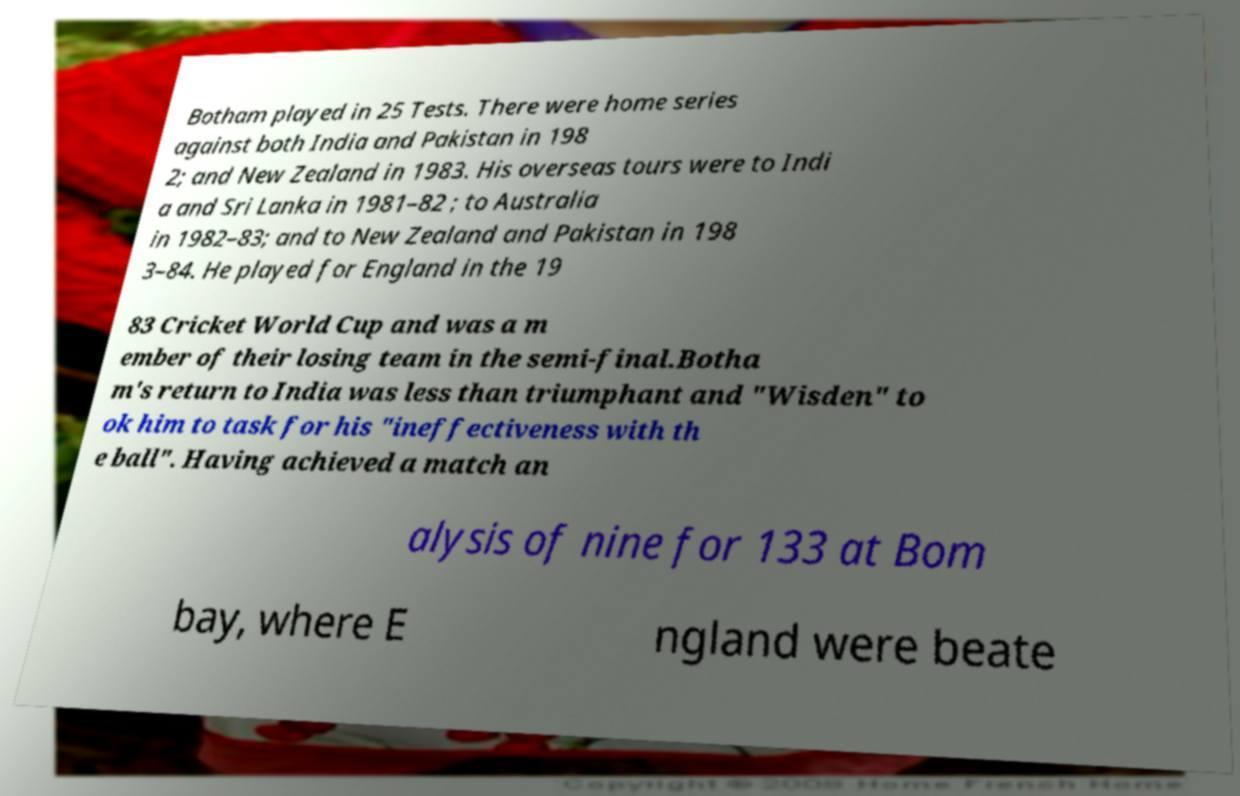There's text embedded in this image that I need extracted. Can you transcribe it verbatim? Botham played in 25 Tests. There were home series against both India and Pakistan in 198 2; and New Zealand in 1983. His overseas tours were to Indi a and Sri Lanka in 1981–82 ; to Australia in 1982–83; and to New Zealand and Pakistan in 198 3–84. He played for England in the 19 83 Cricket World Cup and was a m ember of their losing team in the semi-final.Botha m's return to India was less than triumphant and "Wisden" to ok him to task for his "ineffectiveness with th e ball". Having achieved a match an alysis of nine for 133 at Bom bay, where E ngland were beate 